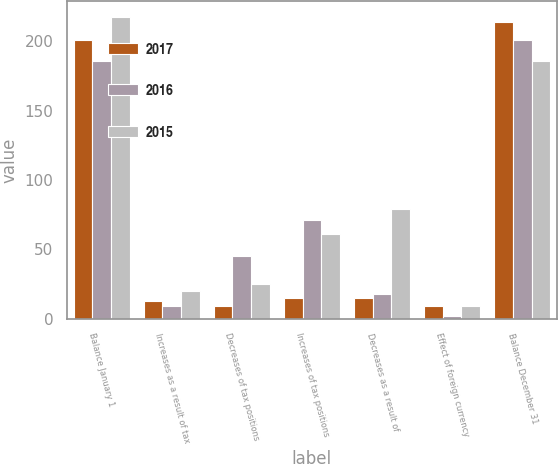Convert chart to OTSL. <chart><loc_0><loc_0><loc_500><loc_500><stacked_bar_chart><ecel><fcel>Balance January 1<fcel>Increases as a result of tax<fcel>Decreases of tax positions<fcel>Increases of tax positions<fcel>Decreases as a result of<fcel>Effect of foreign currency<fcel>Balance December 31<nl><fcel>2017<fcel>201<fcel>13<fcel>9<fcel>15<fcel>15<fcel>9<fcel>214<nl><fcel>2016<fcel>186<fcel>9<fcel>45<fcel>71<fcel>18<fcel>2<fcel>201<nl><fcel>2015<fcel>218<fcel>20<fcel>25<fcel>61<fcel>79<fcel>9<fcel>186<nl></chart> 